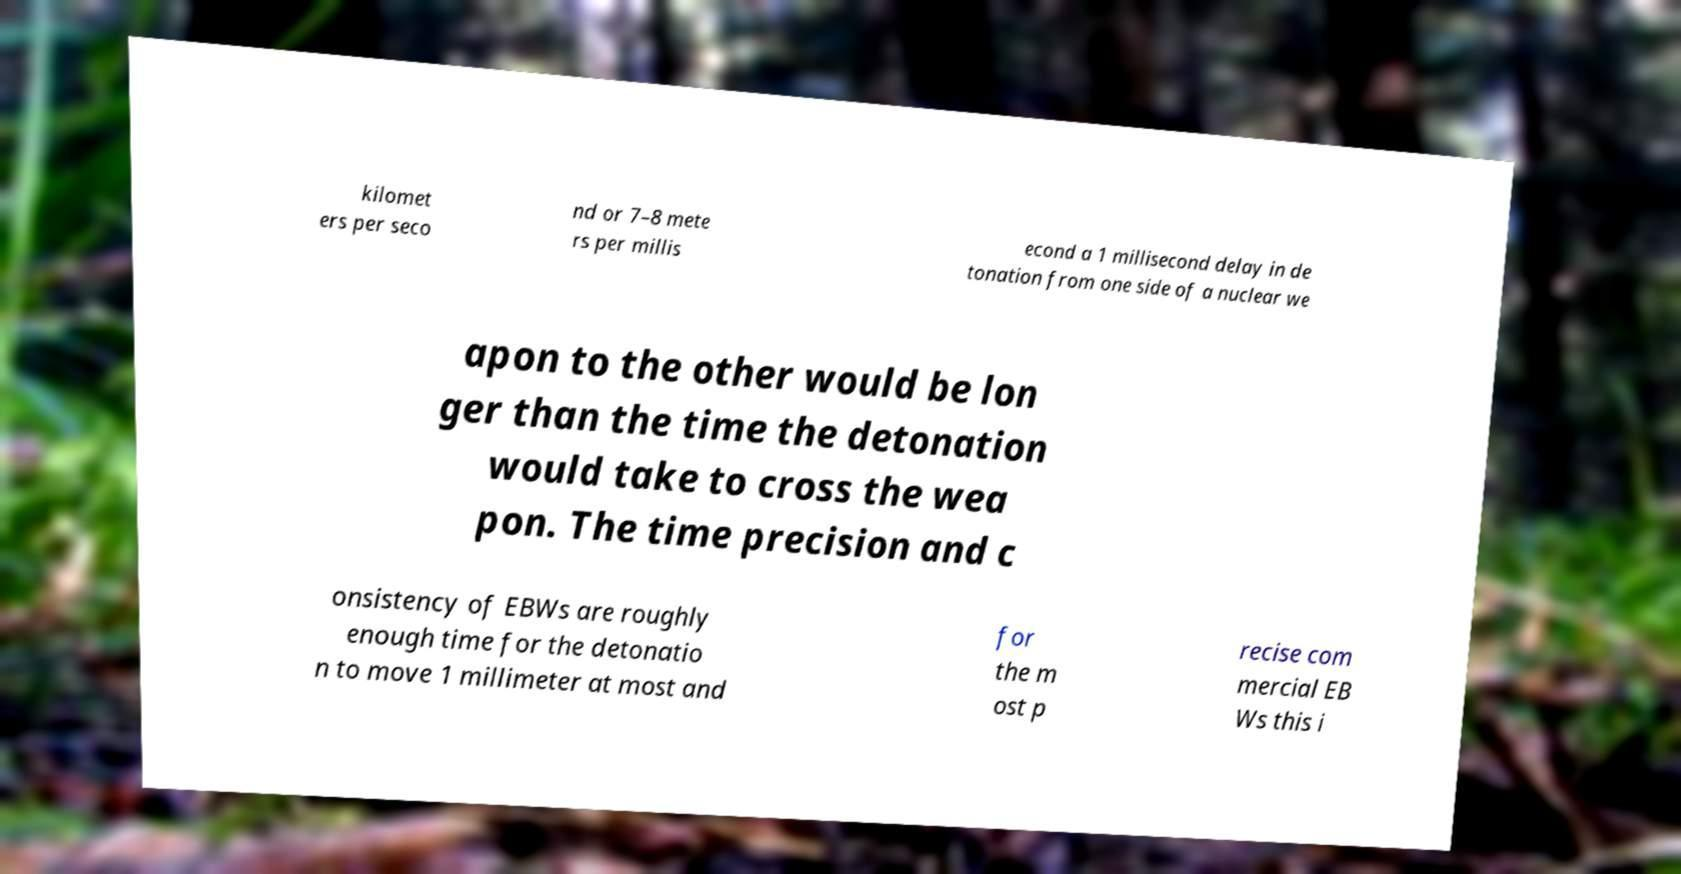There's text embedded in this image that I need extracted. Can you transcribe it verbatim? kilomet ers per seco nd or 7–8 mete rs per millis econd a 1 millisecond delay in de tonation from one side of a nuclear we apon to the other would be lon ger than the time the detonation would take to cross the wea pon. The time precision and c onsistency of EBWs are roughly enough time for the detonatio n to move 1 millimeter at most and for the m ost p recise com mercial EB Ws this i 